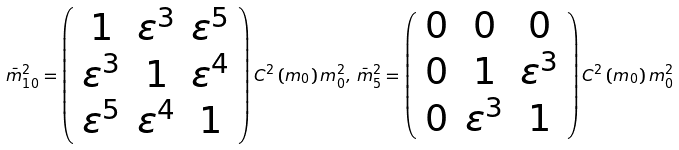<formula> <loc_0><loc_0><loc_500><loc_500>\bar { m } _ { 1 0 } ^ { 2 } = \left ( \begin{array} { c c c } 1 & \varepsilon ^ { 3 } & \varepsilon ^ { 5 } \\ \varepsilon ^ { 3 } & 1 & \varepsilon ^ { 4 } \\ \varepsilon ^ { 5 } & \varepsilon ^ { 4 } & 1 \\ \end{array} \right ) C ^ { 2 } \left ( m _ { 0 } \right ) m _ { 0 } ^ { 2 } , \, \bar { m } _ { 5 } ^ { 2 } = \left ( \begin{array} { c c c } 0 & 0 & 0 \\ 0 & 1 & \varepsilon ^ { 3 } \\ 0 & \varepsilon ^ { 3 } & 1 \\ \end{array} \right ) C ^ { 2 } \left ( m _ { 0 } \right ) m _ { 0 } ^ { 2 }</formula> 